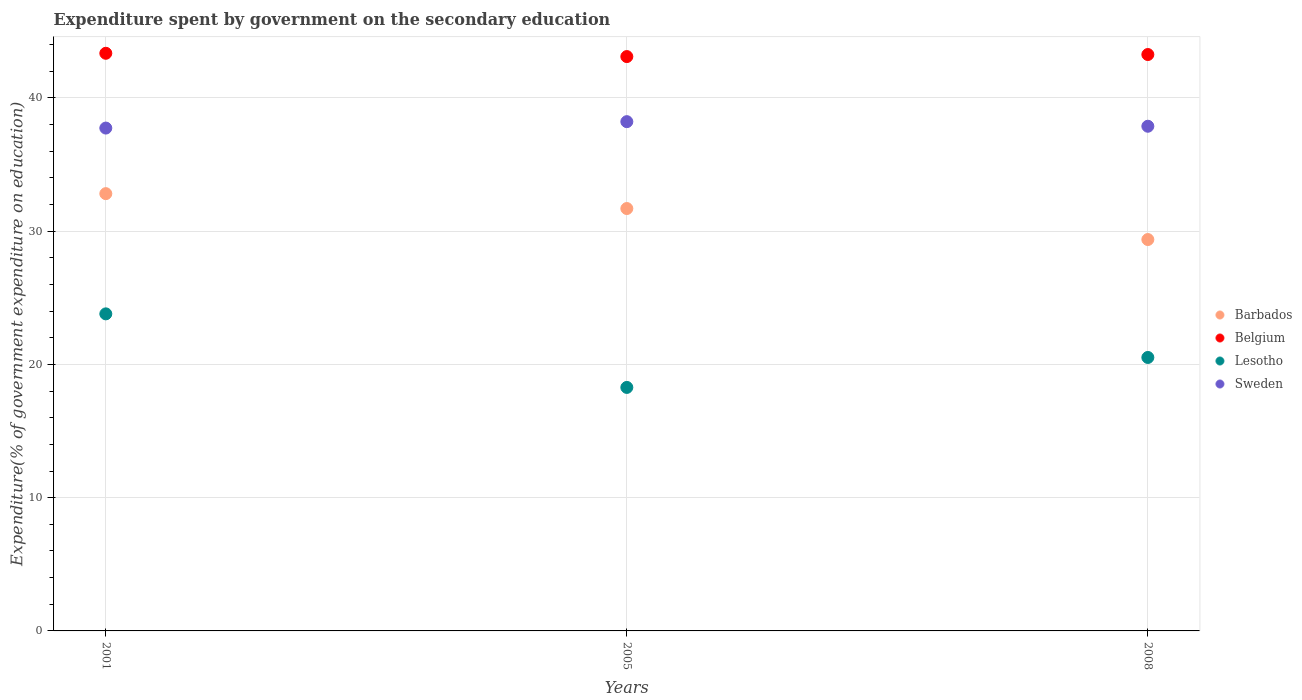What is the expenditure spent by government on the secondary education in Belgium in 2001?
Make the answer very short. 43.35. Across all years, what is the maximum expenditure spent by government on the secondary education in Sweden?
Make the answer very short. 38.21. Across all years, what is the minimum expenditure spent by government on the secondary education in Belgium?
Make the answer very short. 43.1. What is the total expenditure spent by government on the secondary education in Belgium in the graph?
Offer a terse response. 129.7. What is the difference between the expenditure spent by government on the secondary education in Lesotho in 2001 and that in 2005?
Provide a short and direct response. 5.52. What is the difference between the expenditure spent by government on the secondary education in Belgium in 2005 and the expenditure spent by government on the secondary education in Sweden in 2008?
Your response must be concise. 5.23. What is the average expenditure spent by government on the secondary education in Barbados per year?
Ensure brevity in your answer.  31.29. In the year 2001, what is the difference between the expenditure spent by government on the secondary education in Sweden and expenditure spent by government on the secondary education in Lesotho?
Your response must be concise. 13.94. In how many years, is the expenditure spent by government on the secondary education in Sweden greater than 14 %?
Keep it short and to the point. 3. What is the ratio of the expenditure spent by government on the secondary education in Lesotho in 2005 to that in 2008?
Offer a terse response. 0.89. Is the expenditure spent by government on the secondary education in Sweden in 2005 less than that in 2008?
Ensure brevity in your answer.  No. What is the difference between the highest and the second highest expenditure spent by government on the secondary education in Sweden?
Make the answer very short. 0.34. What is the difference between the highest and the lowest expenditure spent by government on the secondary education in Barbados?
Offer a terse response. 3.44. In how many years, is the expenditure spent by government on the secondary education in Sweden greater than the average expenditure spent by government on the secondary education in Sweden taken over all years?
Keep it short and to the point. 1. Is it the case that in every year, the sum of the expenditure spent by government on the secondary education in Lesotho and expenditure spent by government on the secondary education in Barbados  is greater than the expenditure spent by government on the secondary education in Belgium?
Provide a succinct answer. Yes. Is the expenditure spent by government on the secondary education in Lesotho strictly greater than the expenditure spent by government on the secondary education in Barbados over the years?
Make the answer very short. No. Is the expenditure spent by government on the secondary education in Barbados strictly less than the expenditure spent by government on the secondary education in Belgium over the years?
Your answer should be very brief. Yes. How many dotlines are there?
Keep it short and to the point. 4. Does the graph contain grids?
Provide a short and direct response. Yes. Where does the legend appear in the graph?
Provide a short and direct response. Center right. How many legend labels are there?
Keep it short and to the point. 4. How are the legend labels stacked?
Ensure brevity in your answer.  Vertical. What is the title of the graph?
Make the answer very short. Expenditure spent by government on the secondary education. What is the label or title of the X-axis?
Your answer should be compact. Years. What is the label or title of the Y-axis?
Keep it short and to the point. Expenditure(% of government expenditure on education). What is the Expenditure(% of government expenditure on education) in Barbados in 2001?
Make the answer very short. 32.81. What is the Expenditure(% of government expenditure on education) of Belgium in 2001?
Provide a short and direct response. 43.35. What is the Expenditure(% of government expenditure on education) of Lesotho in 2001?
Your answer should be compact. 23.79. What is the Expenditure(% of government expenditure on education) of Sweden in 2001?
Your answer should be compact. 37.73. What is the Expenditure(% of government expenditure on education) in Barbados in 2005?
Offer a very short reply. 31.7. What is the Expenditure(% of government expenditure on education) in Belgium in 2005?
Make the answer very short. 43.1. What is the Expenditure(% of government expenditure on education) in Lesotho in 2005?
Your answer should be very brief. 18.27. What is the Expenditure(% of government expenditure on education) of Sweden in 2005?
Give a very brief answer. 38.21. What is the Expenditure(% of government expenditure on education) of Barbados in 2008?
Offer a very short reply. 29.37. What is the Expenditure(% of government expenditure on education) of Belgium in 2008?
Provide a succinct answer. 43.25. What is the Expenditure(% of government expenditure on education) in Lesotho in 2008?
Provide a short and direct response. 20.52. What is the Expenditure(% of government expenditure on education) in Sweden in 2008?
Your answer should be very brief. 37.87. Across all years, what is the maximum Expenditure(% of government expenditure on education) in Barbados?
Make the answer very short. 32.81. Across all years, what is the maximum Expenditure(% of government expenditure on education) of Belgium?
Your answer should be very brief. 43.35. Across all years, what is the maximum Expenditure(% of government expenditure on education) in Lesotho?
Keep it short and to the point. 23.79. Across all years, what is the maximum Expenditure(% of government expenditure on education) of Sweden?
Your response must be concise. 38.21. Across all years, what is the minimum Expenditure(% of government expenditure on education) in Barbados?
Make the answer very short. 29.37. Across all years, what is the minimum Expenditure(% of government expenditure on education) of Belgium?
Provide a succinct answer. 43.1. Across all years, what is the minimum Expenditure(% of government expenditure on education) in Lesotho?
Your answer should be very brief. 18.27. Across all years, what is the minimum Expenditure(% of government expenditure on education) in Sweden?
Keep it short and to the point. 37.73. What is the total Expenditure(% of government expenditure on education) of Barbados in the graph?
Make the answer very short. 93.88. What is the total Expenditure(% of government expenditure on education) of Belgium in the graph?
Your response must be concise. 129.7. What is the total Expenditure(% of government expenditure on education) in Lesotho in the graph?
Provide a succinct answer. 62.58. What is the total Expenditure(% of government expenditure on education) in Sweden in the graph?
Give a very brief answer. 113.82. What is the difference between the Expenditure(% of government expenditure on education) of Barbados in 2001 and that in 2005?
Offer a very short reply. 1.12. What is the difference between the Expenditure(% of government expenditure on education) of Belgium in 2001 and that in 2005?
Keep it short and to the point. 0.25. What is the difference between the Expenditure(% of government expenditure on education) in Lesotho in 2001 and that in 2005?
Offer a very short reply. 5.52. What is the difference between the Expenditure(% of government expenditure on education) in Sweden in 2001 and that in 2005?
Offer a terse response. -0.48. What is the difference between the Expenditure(% of government expenditure on education) in Barbados in 2001 and that in 2008?
Your response must be concise. 3.44. What is the difference between the Expenditure(% of government expenditure on education) of Belgium in 2001 and that in 2008?
Ensure brevity in your answer.  0.09. What is the difference between the Expenditure(% of government expenditure on education) in Lesotho in 2001 and that in 2008?
Ensure brevity in your answer.  3.27. What is the difference between the Expenditure(% of government expenditure on education) in Sweden in 2001 and that in 2008?
Your answer should be very brief. -0.14. What is the difference between the Expenditure(% of government expenditure on education) in Barbados in 2005 and that in 2008?
Ensure brevity in your answer.  2.33. What is the difference between the Expenditure(% of government expenditure on education) in Belgium in 2005 and that in 2008?
Your answer should be compact. -0.15. What is the difference between the Expenditure(% of government expenditure on education) of Lesotho in 2005 and that in 2008?
Offer a terse response. -2.25. What is the difference between the Expenditure(% of government expenditure on education) in Sweden in 2005 and that in 2008?
Give a very brief answer. 0.34. What is the difference between the Expenditure(% of government expenditure on education) of Barbados in 2001 and the Expenditure(% of government expenditure on education) of Belgium in 2005?
Your answer should be very brief. -10.29. What is the difference between the Expenditure(% of government expenditure on education) of Barbados in 2001 and the Expenditure(% of government expenditure on education) of Lesotho in 2005?
Provide a short and direct response. 14.54. What is the difference between the Expenditure(% of government expenditure on education) in Barbados in 2001 and the Expenditure(% of government expenditure on education) in Sweden in 2005?
Offer a terse response. -5.4. What is the difference between the Expenditure(% of government expenditure on education) in Belgium in 2001 and the Expenditure(% of government expenditure on education) in Lesotho in 2005?
Offer a very short reply. 25.07. What is the difference between the Expenditure(% of government expenditure on education) of Belgium in 2001 and the Expenditure(% of government expenditure on education) of Sweden in 2005?
Your answer should be very brief. 5.13. What is the difference between the Expenditure(% of government expenditure on education) in Lesotho in 2001 and the Expenditure(% of government expenditure on education) in Sweden in 2005?
Provide a short and direct response. -14.42. What is the difference between the Expenditure(% of government expenditure on education) in Barbados in 2001 and the Expenditure(% of government expenditure on education) in Belgium in 2008?
Your answer should be very brief. -10.44. What is the difference between the Expenditure(% of government expenditure on education) of Barbados in 2001 and the Expenditure(% of government expenditure on education) of Lesotho in 2008?
Offer a very short reply. 12.29. What is the difference between the Expenditure(% of government expenditure on education) in Barbados in 2001 and the Expenditure(% of government expenditure on education) in Sweden in 2008?
Offer a very short reply. -5.06. What is the difference between the Expenditure(% of government expenditure on education) of Belgium in 2001 and the Expenditure(% of government expenditure on education) of Lesotho in 2008?
Provide a short and direct response. 22.83. What is the difference between the Expenditure(% of government expenditure on education) of Belgium in 2001 and the Expenditure(% of government expenditure on education) of Sweden in 2008?
Make the answer very short. 5.47. What is the difference between the Expenditure(% of government expenditure on education) of Lesotho in 2001 and the Expenditure(% of government expenditure on education) of Sweden in 2008?
Ensure brevity in your answer.  -14.08. What is the difference between the Expenditure(% of government expenditure on education) of Barbados in 2005 and the Expenditure(% of government expenditure on education) of Belgium in 2008?
Provide a short and direct response. -11.56. What is the difference between the Expenditure(% of government expenditure on education) in Barbados in 2005 and the Expenditure(% of government expenditure on education) in Lesotho in 2008?
Make the answer very short. 11.18. What is the difference between the Expenditure(% of government expenditure on education) in Barbados in 2005 and the Expenditure(% of government expenditure on education) in Sweden in 2008?
Your response must be concise. -6.17. What is the difference between the Expenditure(% of government expenditure on education) in Belgium in 2005 and the Expenditure(% of government expenditure on education) in Lesotho in 2008?
Offer a terse response. 22.58. What is the difference between the Expenditure(% of government expenditure on education) of Belgium in 2005 and the Expenditure(% of government expenditure on education) of Sweden in 2008?
Your response must be concise. 5.23. What is the difference between the Expenditure(% of government expenditure on education) of Lesotho in 2005 and the Expenditure(% of government expenditure on education) of Sweden in 2008?
Provide a short and direct response. -19.6. What is the average Expenditure(% of government expenditure on education) of Barbados per year?
Give a very brief answer. 31.29. What is the average Expenditure(% of government expenditure on education) in Belgium per year?
Offer a very short reply. 43.23. What is the average Expenditure(% of government expenditure on education) in Lesotho per year?
Make the answer very short. 20.86. What is the average Expenditure(% of government expenditure on education) in Sweden per year?
Your response must be concise. 37.94. In the year 2001, what is the difference between the Expenditure(% of government expenditure on education) in Barbados and Expenditure(% of government expenditure on education) in Belgium?
Provide a short and direct response. -10.53. In the year 2001, what is the difference between the Expenditure(% of government expenditure on education) of Barbados and Expenditure(% of government expenditure on education) of Lesotho?
Provide a short and direct response. 9.02. In the year 2001, what is the difference between the Expenditure(% of government expenditure on education) in Barbados and Expenditure(% of government expenditure on education) in Sweden?
Keep it short and to the point. -4.92. In the year 2001, what is the difference between the Expenditure(% of government expenditure on education) in Belgium and Expenditure(% of government expenditure on education) in Lesotho?
Provide a short and direct response. 19.55. In the year 2001, what is the difference between the Expenditure(% of government expenditure on education) in Belgium and Expenditure(% of government expenditure on education) in Sweden?
Make the answer very short. 5.61. In the year 2001, what is the difference between the Expenditure(% of government expenditure on education) of Lesotho and Expenditure(% of government expenditure on education) of Sweden?
Your response must be concise. -13.94. In the year 2005, what is the difference between the Expenditure(% of government expenditure on education) in Barbados and Expenditure(% of government expenditure on education) in Belgium?
Offer a very short reply. -11.4. In the year 2005, what is the difference between the Expenditure(% of government expenditure on education) of Barbados and Expenditure(% of government expenditure on education) of Lesotho?
Ensure brevity in your answer.  13.42. In the year 2005, what is the difference between the Expenditure(% of government expenditure on education) in Barbados and Expenditure(% of government expenditure on education) in Sweden?
Offer a very short reply. -6.52. In the year 2005, what is the difference between the Expenditure(% of government expenditure on education) in Belgium and Expenditure(% of government expenditure on education) in Lesotho?
Provide a succinct answer. 24.83. In the year 2005, what is the difference between the Expenditure(% of government expenditure on education) of Belgium and Expenditure(% of government expenditure on education) of Sweden?
Offer a very short reply. 4.88. In the year 2005, what is the difference between the Expenditure(% of government expenditure on education) in Lesotho and Expenditure(% of government expenditure on education) in Sweden?
Offer a terse response. -19.94. In the year 2008, what is the difference between the Expenditure(% of government expenditure on education) of Barbados and Expenditure(% of government expenditure on education) of Belgium?
Your answer should be very brief. -13.88. In the year 2008, what is the difference between the Expenditure(% of government expenditure on education) of Barbados and Expenditure(% of government expenditure on education) of Lesotho?
Make the answer very short. 8.85. In the year 2008, what is the difference between the Expenditure(% of government expenditure on education) of Barbados and Expenditure(% of government expenditure on education) of Sweden?
Provide a short and direct response. -8.5. In the year 2008, what is the difference between the Expenditure(% of government expenditure on education) of Belgium and Expenditure(% of government expenditure on education) of Lesotho?
Your response must be concise. 22.73. In the year 2008, what is the difference between the Expenditure(% of government expenditure on education) in Belgium and Expenditure(% of government expenditure on education) in Sweden?
Your response must be concise. 5.38. In the year 2008, what is the difference between the Expenditure(% of government expenditure on education) in Lesotho and Expenditure(% of government expenditure on education) in Sweden?
Your answer should be compact. -17.35. What is the ratio of the Expenditure(% of government expenditure on education) of Barbados in 2001 to that in 2005?
Offer a very short reply. 1.04. What is the ratio of the Expenditure(% of government expenditure on education) in Belgium in 2001 to that in 2005?
Make the answer very short. 1.01. What is the ratio of the Expenditure(% of government expenditure on education) in Lesotho in 2001 to that in 2005?
Your answer should be compact. 1.3. What is the ratio of the Expenditure(% of government expenditure on education) of Sweden in 2001 to that in 2005?
Make the answer very short. 0.99. What is the ratio of the Expenditure(% of government expenditure on education) in Barbados in 2001 to that in 2008?
Make the answer very short. 1.12. What is the ratio of the Expenditure(% of government expenditure on education) in Belgium in 2001 to that in 2008?
Ensure brevity in your answer.  1. What is the ratio of the Expenditure(% of government expenditure on education) in Lesotho in 2001 to that in 2008?
Provide a short and direct response. 1.16. What is the ratio of the Expenditure(% of government expenditure on education) in Sweden in 2001 to that in 2008?
Your answer should be compact. 1. What is the ratio of the Expenditure(% of government expenditure on education) of Barbados in 2005 to that in 2008?
Your response must be concise. 1.08. What is the ratio of the Expenditure(% of government expenditure on education) in Belgium in 2005 to that in 2008?
Provide a short and direct response. 1. What is the ratio of the Expenditure(% of government expenditure on education) of Lesotho in 2005 to that in 2008?
Provide a succinct answer. 0.89. What is the ratio of the Expenditure(% of government expenditure on education) in Sweden in 2005 to that in 2008?
Your answer should be very brief. 1.01. What is the difference between the highest and the second highest Expenditure(% of government expenditure on education) in Barbados?
Your answer should be very brief. 1.12. What is the difference between the highest and the second highest Expenditure(% of government expenditure on education) in Belgium?
Your response must be concise. 0.09. What is the difference between the highest and the second highest Expenditure(% of government expenditure on education) of Lesotho?
Give a very brief answer. 3.27. What is the difference between the highest and the second highest Expenditure(% of government expenditure on education) in Sweden?
Your answer should be very brief. 0.34. What is the difference between the highest and the lowest Expenditure(% of government expenditure on education) of Barbados?
Your answer should be very brief. 3.44. What is the difference between the highest and the lowest Expenditure(% of government expenditure on education) of Belgium?
Ensure brevity in your answer.  0.25. What is the difference between the highest and the lowest Expenditure(% of government expenditure on education) of Lesotho?
Your answer should be compact. 5.52. What is the difference between the highest and the lowest Expenditure(% of government expenditure on education) of Sweden?
Your response must be concise. 0.48. 